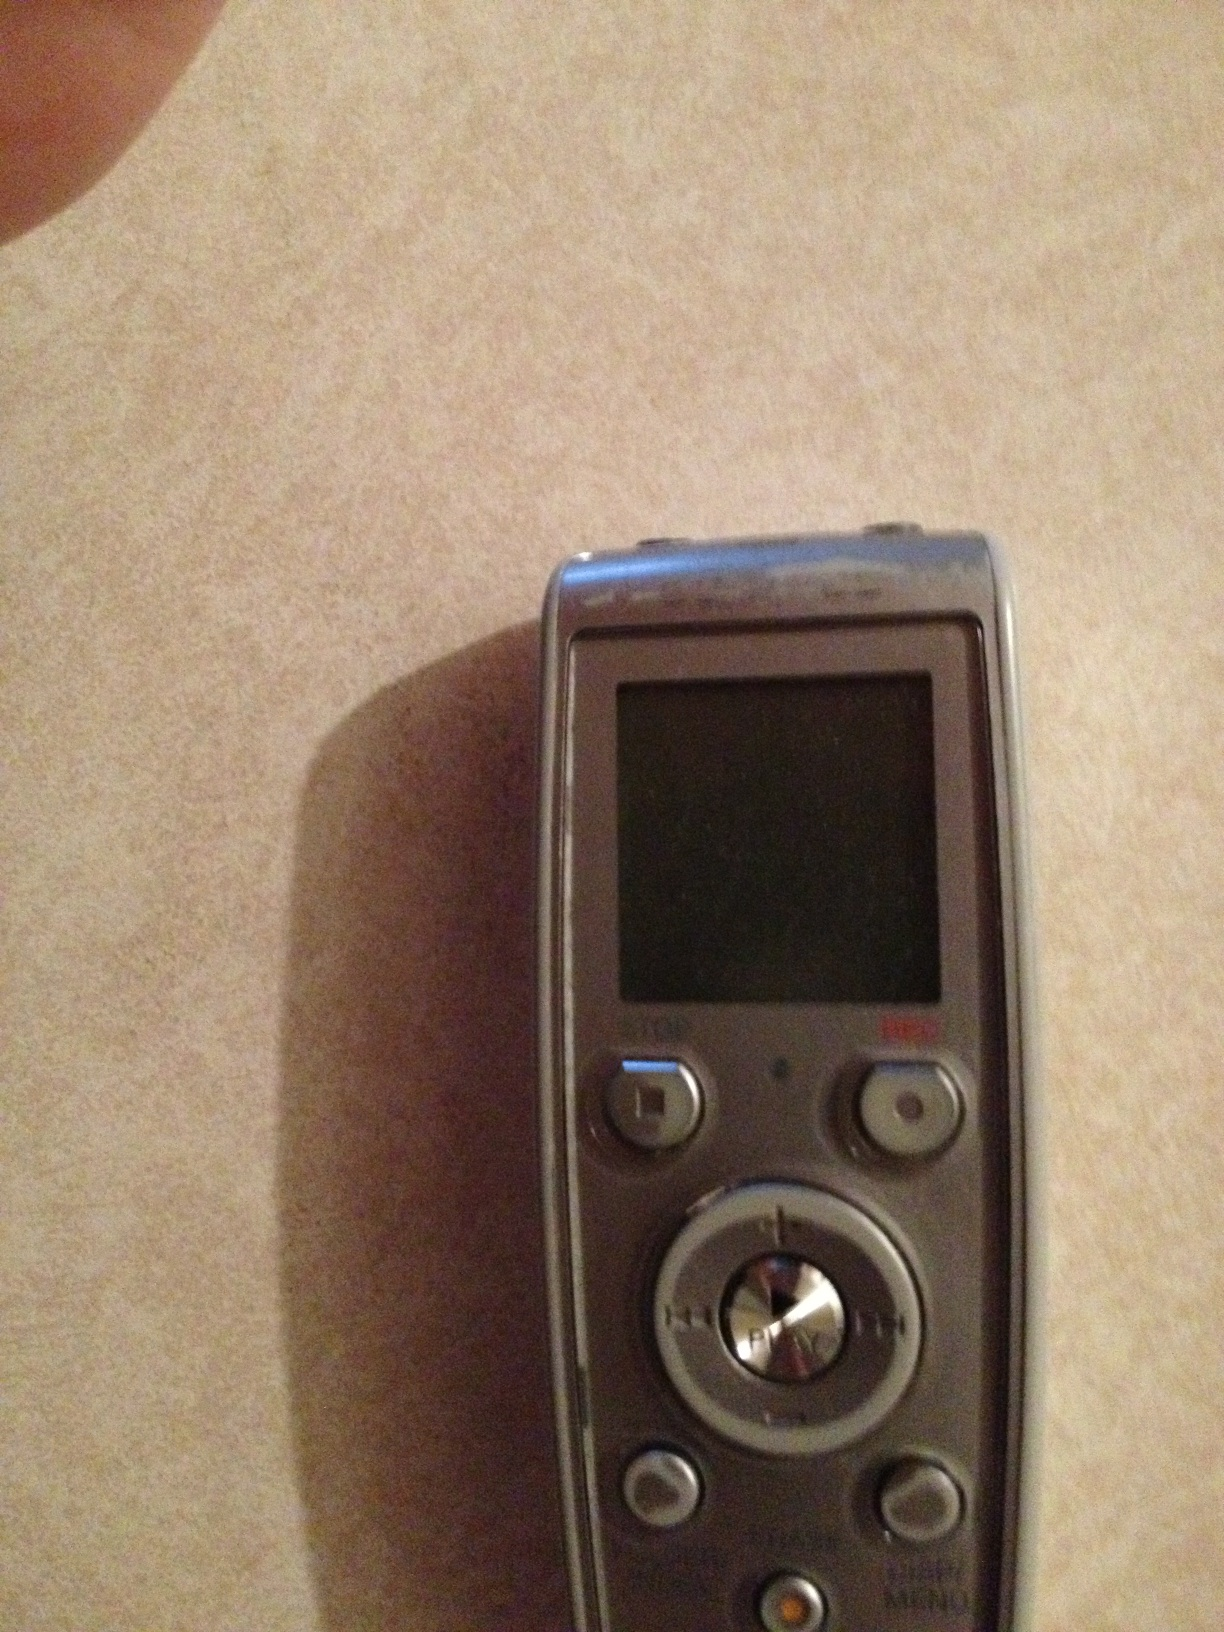What is this? This is a digital voice recorder, commonly used for recording audio such as lectures, interviews, and personal notes. It has buttons for play, stop, record, and other functionalities to manage audio files. 